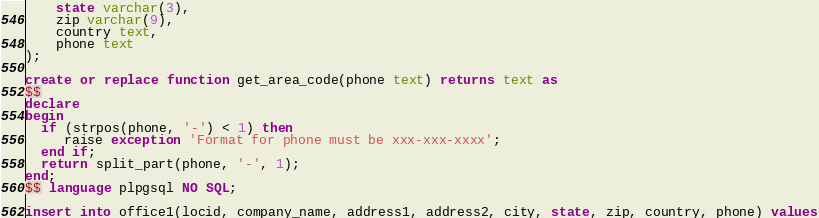<code> <loc_0><loc_0><loc_500><loc_500><_SQL_>    state varchar(3),
    zip varchar(9),
    country text,
    phone text
);

create or replace function get_area_code(phone text) returns text as
$$
declare
begin
  if (strpos(phone, '-') < 1) then
     raise exception 'Format for phone must be xxx-xxx-xxxx';
  end if;
  return split_part(phone, '-', 1);
end;
$$ language plpgsql NO SQL;

insert into office1(locid, company_name, address1, address2, city, state, zip, country, phone) values</code> 